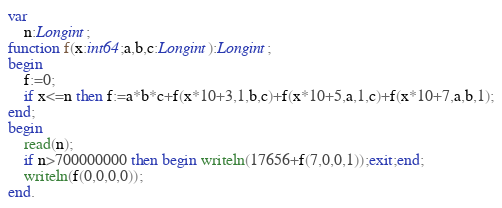Convert code to text. <code><loc_0><loc_0><loc_500><loc_500><_Pascal_>var
	n:Longint;
function f(x:int64;a,b,c:Longint):Longint;
begin
	f:=0;
	if x<=n then f:=a*b*c+f(x*10+3,1,b,c)+f(x*10+5,a,1,c)+f(x*10+7,a,b,1);
end;
begin
	read(n);
	if n>700000000 then begin writeln(17656+f(7,0,0,1));exit;end;
	writeln(f(0,0,0,0));
end.</code> 